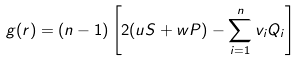<formula> <loc_0><loc_0><loc_500><loc_500>g ( r ) = ( n - 1 ) \left [ 2 ( u S + w P ) - \sum _ { i = 1 } ^ { n } v _ { i } Q _ { i } \right ]</formula> 